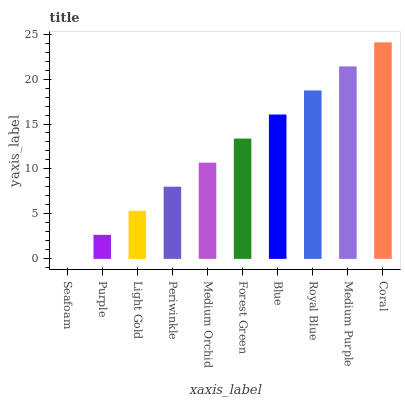Is Purple the minimum?
Answer yes or no. No. Is Purple the maximum?
Answer yes or no. No. Is Purple greater than Seafoam?
Answer yes or no. Yes. Is Seafoam less than Purple?
Answer yes or no. Yes. Is Seafoam greater than Purple?
Answer yes or no. No. Is Purple less than Seafoam?
Answer yes or no. No. Is Forest Green the high median?
Answer yes or no. Yes. Is Medium Orchid the low median?
Answer yes or no. Yes. Is Coral the high median?
Answer yes or no. No. Is Purple the low median?
Answer yes or no. No. 